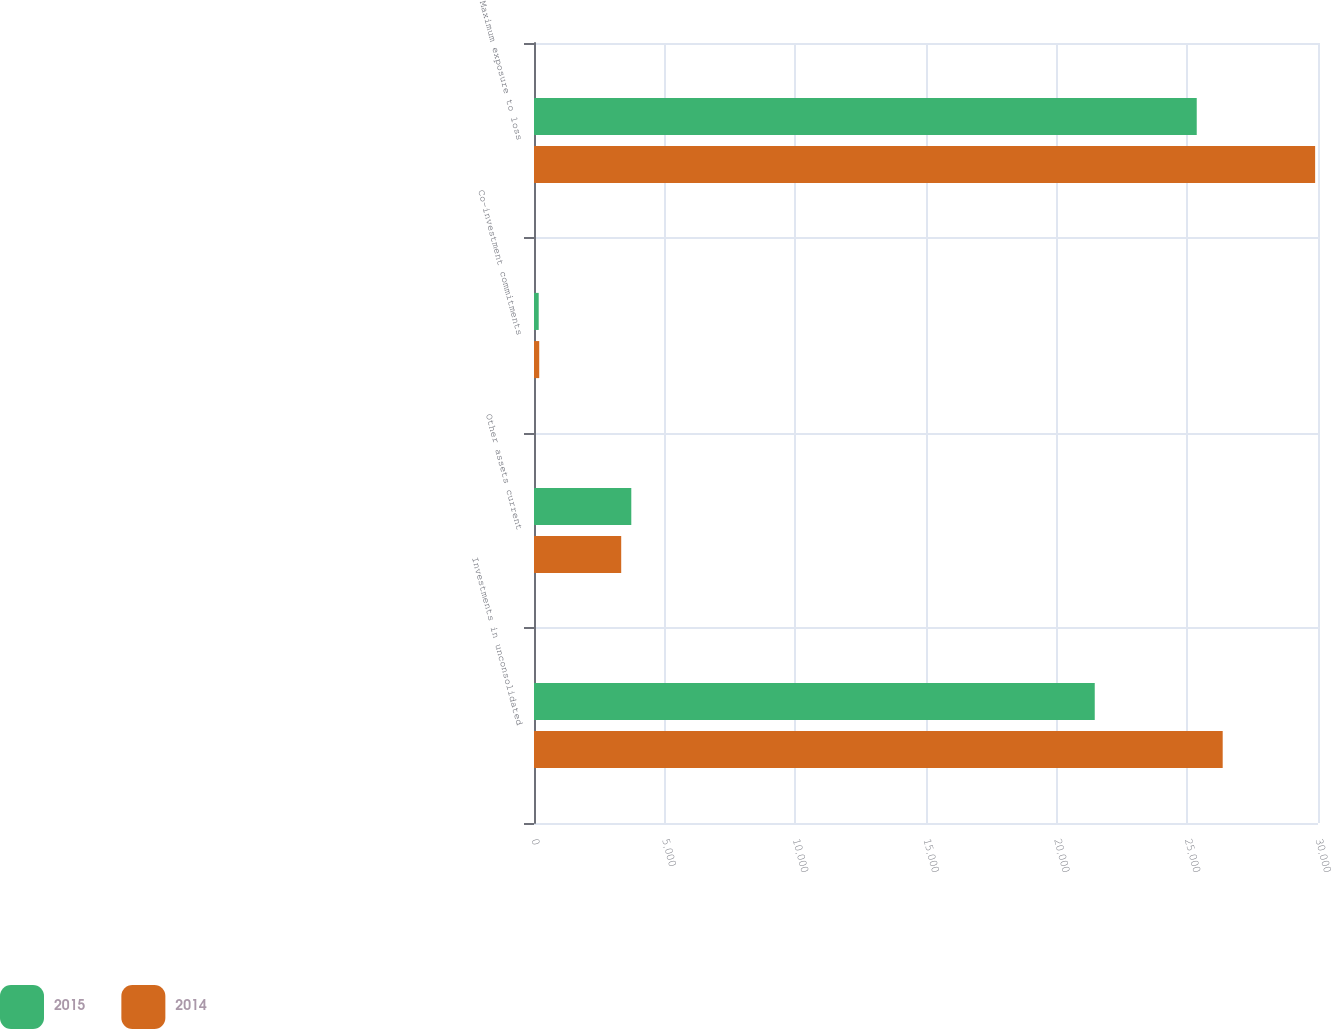<chart> <loc_0><loc_0><loc_500><loc_500><stacked_bar_chart><ecel><fcel>Investments in unconsolidated<fcel>Other assets current<fcel>Co-investment commitments<fcel>Maximum exposure to loss<nl><fcel>2015<fcel>21457<fcel>3723<fcel>180<fcel>25360<nl><fcel>2014<fcel>26353<fcel>3337<fcel>200<fcel>29890<nl></chart> 